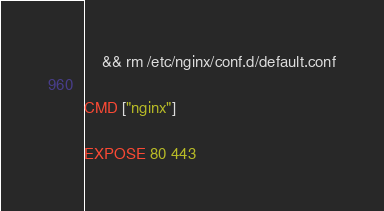<code> <loc_0><loc_0><loc_500><loc_500><_Dockerfile_>    && rm /etc/nginx/conf.d/default.conf

CMD ["nginx"]

EXPOSE 80 443
</code> 